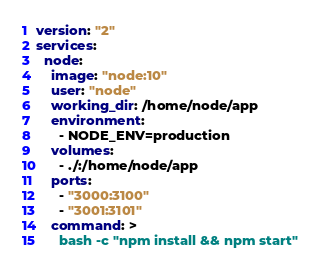<code> <loc_0><loc_0><loc_500><loc_500><_YAML_>version: "2"
services:
  node:
    image: "node:10"
    user: "node"
    working_dir: /home/node/app
    environment:
      - NODE_ENV=production
    volumes:
      - ./:/home/node/app
    ports:
      - "3000:3100"
      - "3001:3101"
    command: >
      bash -c "npm install && npm start"</code> 